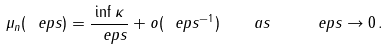<formula> <loc_0><loc_0><loc_500><loc_500>\mu _ { n } ( \ e p s ) = \frac { \inf \kappa } { \ e p s } + o ( \ e p s ^ { - 1 } ) \quad a s \quad \ e p s \to 0 \, .</formula> 